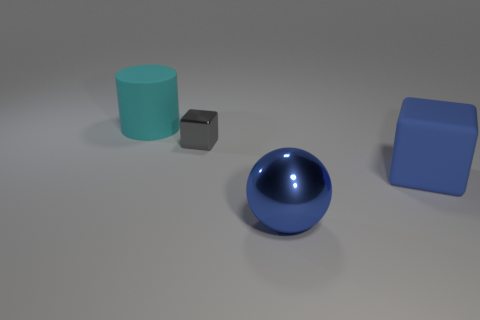Is the number of cyan matte objects that are in front of the tiny gray object less than the number of cubes? yes 